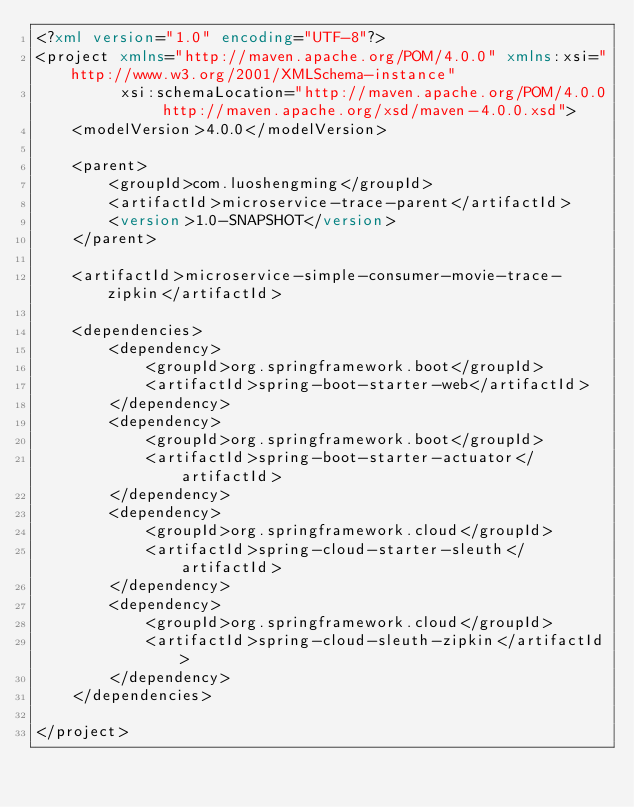Convert code to text. <code><loc_0><loc_0><loc_500><loc_500><_XML_><?xml version="1.0" encoding="UTF-8"?>
<project xmlns="http://maven.apache.org/POM/4.0.0" xmlns:xsi="http://www.w3.org/2001/XMLSchema-instance"
         xsi:schemaLocation="http://maven.apache.org/POM/4.0.0 http://maven.apache.org/xsd/maven-4.0.0.xsd">
    <modelVersion>4.0.0</modelVersion>

    <parent>
        <groupId>com.luoshengming</groupId>
        <artifactId>microservice-trace-parent</artifactId>
        <version>1.0-SNAPSHOT</version>
    </parent>

    <artifactId>microservice-simple-consumer-movie-trace-zipkin</artifactId>

    <dependencies>
        <dependency>
            <groupId>org.springframework.boot</groupId>
            <artifactId>spring-boot-starter-web</artifactId>
        </dependency>
        <dependency>
            <groupId>org.springframework.boot</groupId>
            <artifactId>spring-boot-starter-actuator</artifactId>
        </dependency>
        <dependency>
            <groupId>org.springframework.cloud</groupId>
            <artifactId>spring-cloud-starter-sleuth</artifactId>
        </dependency>
        <dependency>
            <groupId>org.springframework.cloud</groupId>
            <artifactId>spring-cloud-sleuth-zipkin</artifactId>
        </dependency>
    </dependencies>

</project>
</code> 